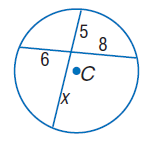Answer the mathemtical geometry problem and directly provide the correct option letter.
Question: Find x. Assume that segments that appear to be tangent are tangent.
Choices: A: 6 B: 8 C: 9.6 D: 14.6 C 